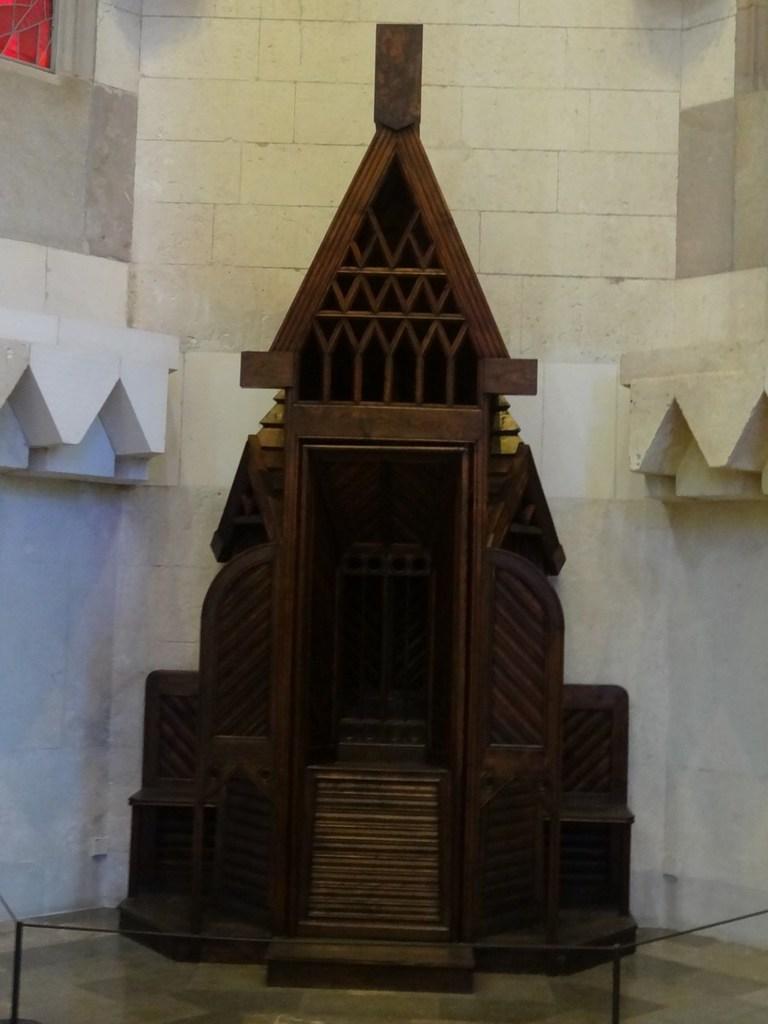Please provide a concise description of this image. This image consists of a building. In which there is a wooden block. It is made in the shape of church. At the bottom, there is a floor. On the left top, there is a window. 